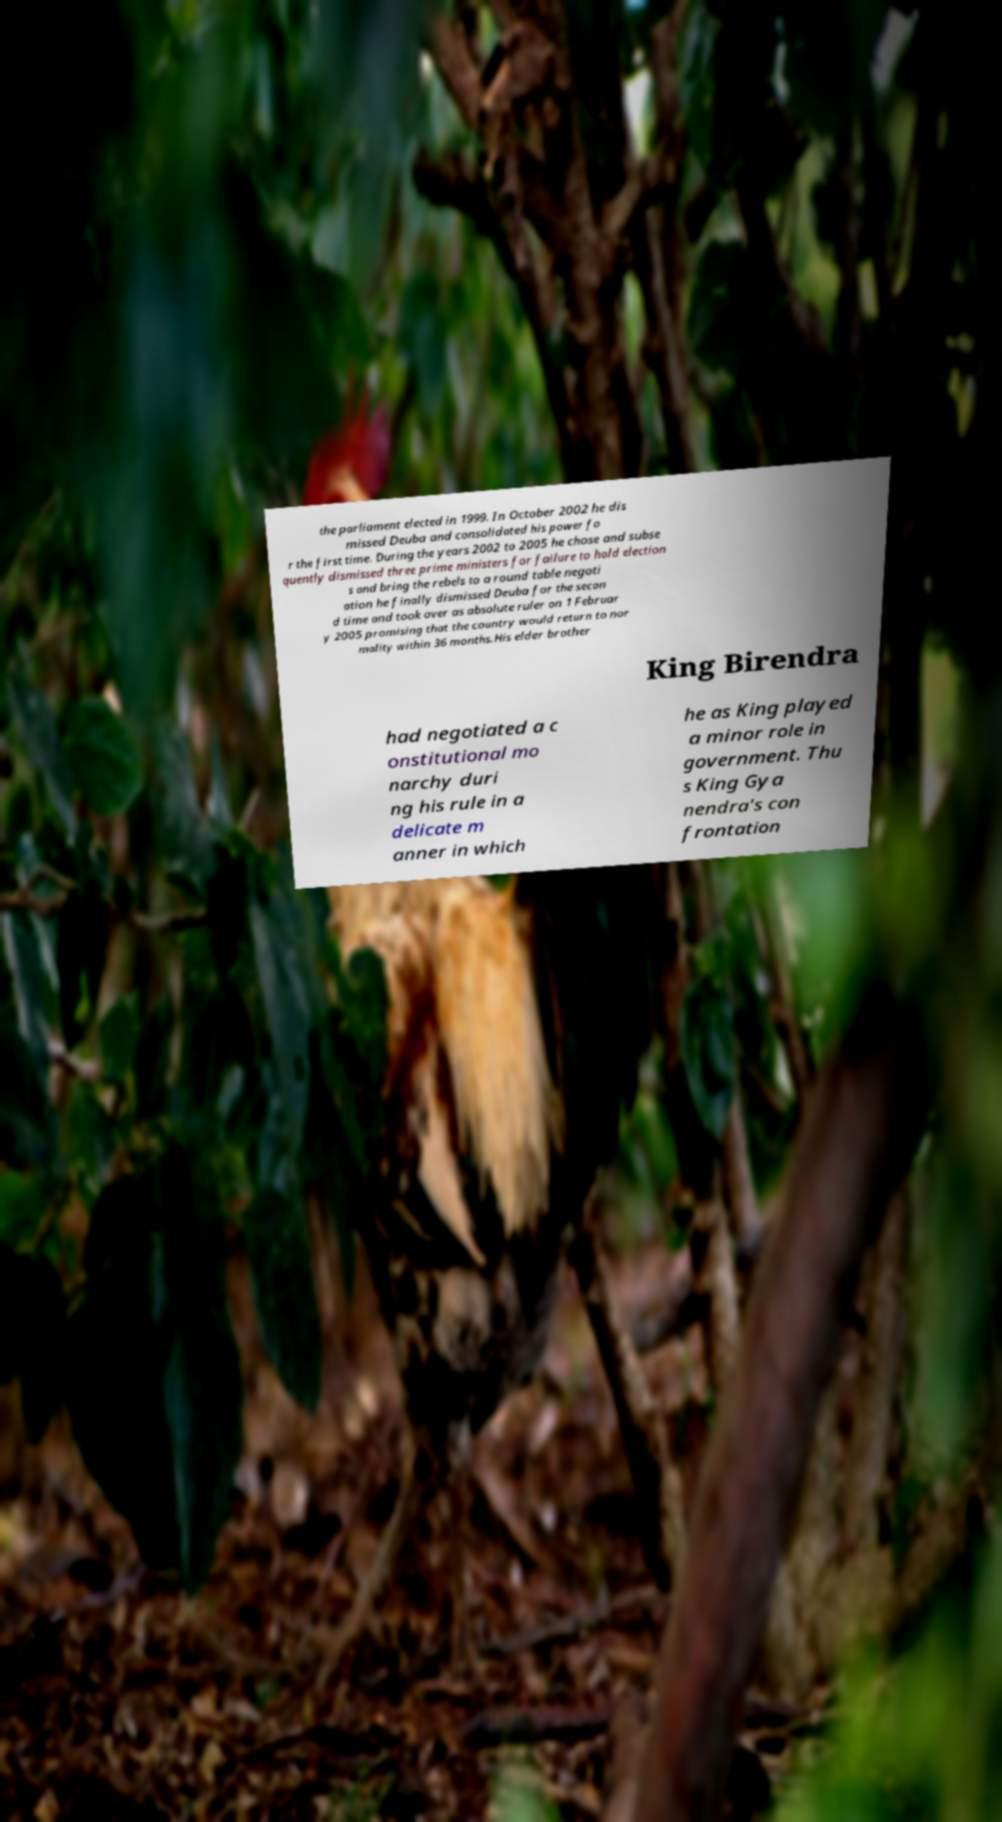There's text embedded in this image that I need extracted. Can you transcribe it verbatim? the parliament elected in 1999. In October 2002 he dis missed Deuba and consolidated his power fo r the first time. During the years 2002 to 2005 he chose and subse quently dismissed three prime ministers for failure to hold election s and bring the rebels to a round table negoti ation he finally dismissed Deuba for the secon d time and took over as absolute ruler on 1 Februar y 2005 promising that the country would return to nor mality within 36 months.His elder brother King Birendra had negotiated a c onstitutional mo narchy duri ng his rule in a delicate m anner in which he as King played a minor role in government. Thu s King Gya nendra's con frontation 